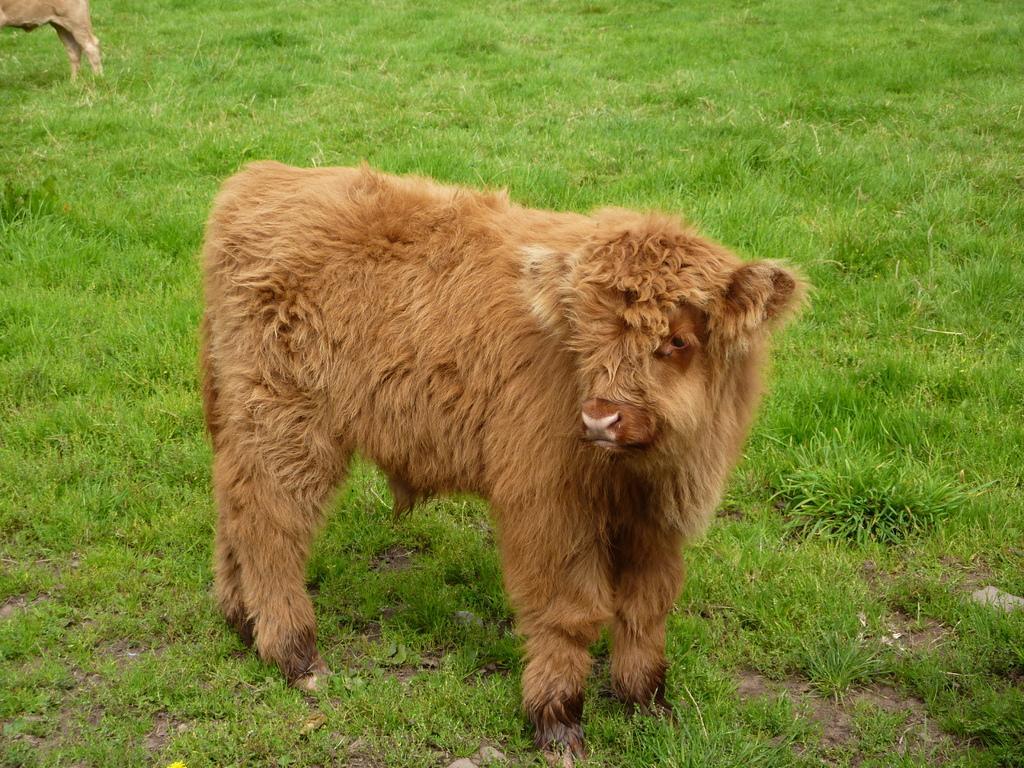Could you give a brief overview of what you see in this image? In this image we can see two animals standing on the ground. 